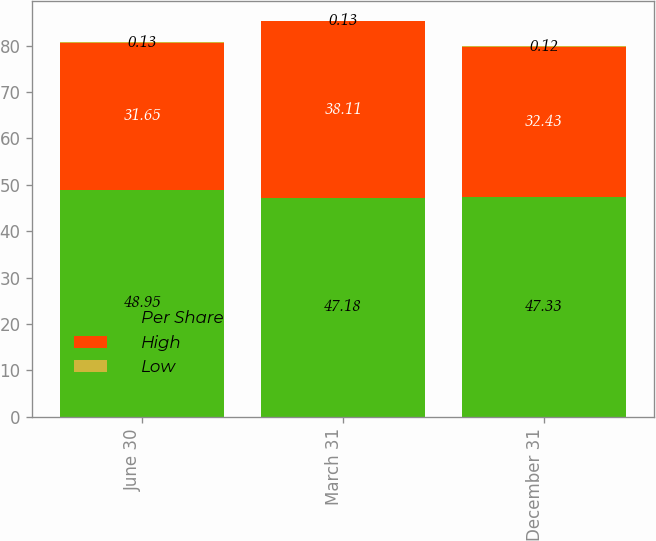Convert chart to OTSL. <chart><loc_0><loc_0><loc_500><loc_500><stacked_bar_chart><ecel><fcel>June 30<fcel>March 31<fcel>December 31<nl><fcel>Per Share<fcel>48.95<fcel>47.18<fcel>47.33<nl><fcel>High<fcel>31.65<fcel>38.11<fcel>32.43<nl><fcel>Low<fcel>0.13<fcel>0.13<fcel>0.12<nl></chart> 